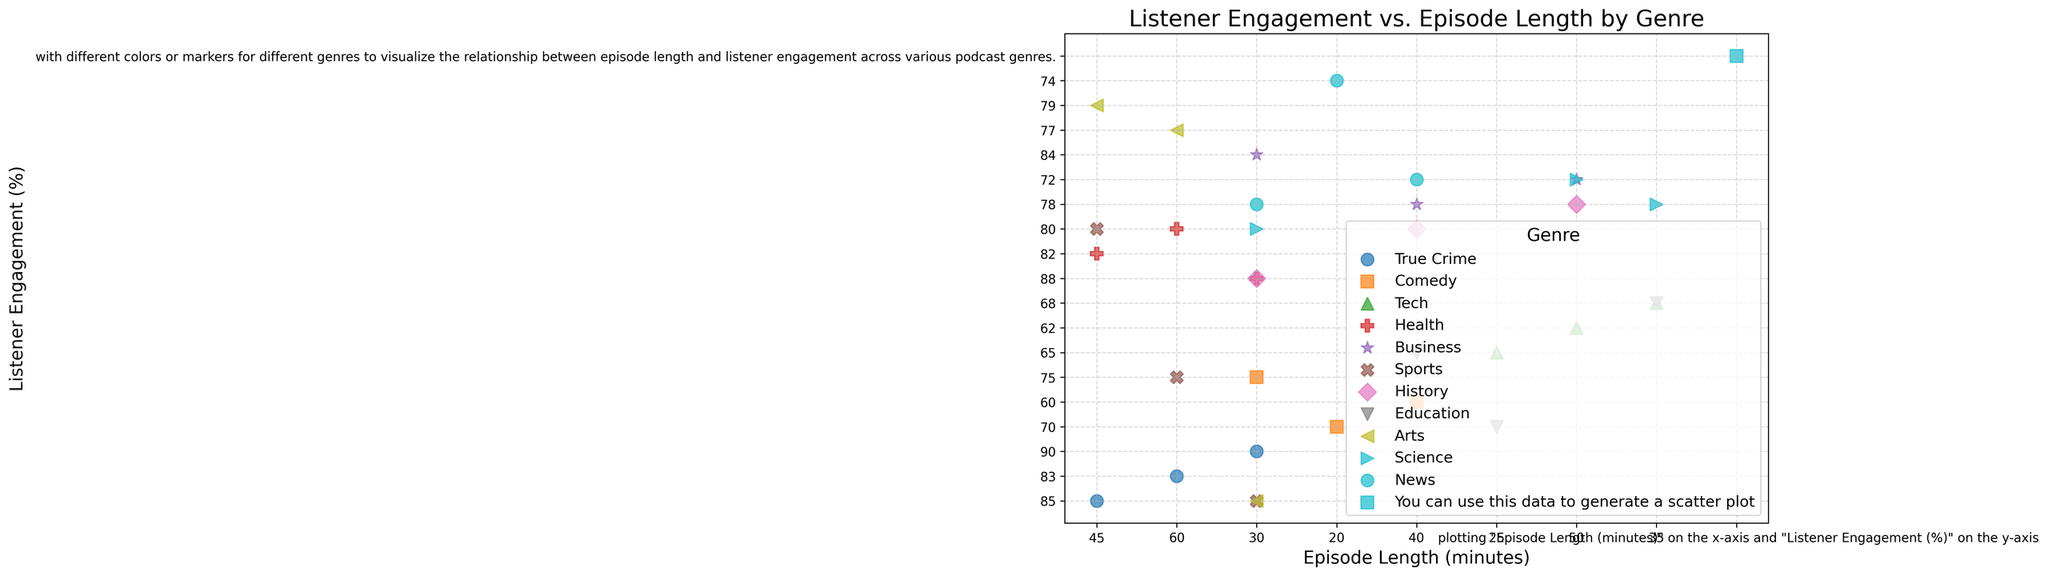What genre shows the highest listener engagement for episode lengths around 30 minutes? Look at the scatter plot, focusing on episode lengths around 30 minutes. Observe which genre's data points are the highest on the y-axis.
Answer: True Crime Which genre has the widest range of episode lengths? Look at each genre's spread on the x-axis (Episode Length). Identify which genre has data points spread out over the longest range.
Answer: Tech Is there a genre where listener engagement tends to decrease as episode length increases? Check the trend (slope direction) of the scatter plot markers for each genre. Identify if there's a genre where the markers consistently go downwards as you move rightwards along the x-axis.
Answer: Comedy Between Sports and Health genres, which one has higher average listener engagement for 45-minute episodes? Identify the data points for 45-minute episodes in both genres. Compare the y-axis (Listener Engagement) values of these data points.
Answer: Health Which genre has a cluster of high listener engagement (above 80%) for episodes shorter than 40 minutes? Focus on the data points above the 80% mark on the y-axis. Check which genre has multiple data points within that subset and episode lengths under 40 minutes.
Answer: Health For episodes around 50 minutes, which genre has the most varied listener engagement? Look at the scatter plot for episodes around 50 minutes on the x-axis and observe the spread of y-values (Listener Engagement) for each genre.
Answer: Tech Do any genres reach listener engagement of 90% or above? If so, which genres? Check the topmost points on the y-axis for values of 90% or more. Note the corresponding genres of these points.
Answer: True Crime, Health, History Is there any genre with consistently low listener engagement, regardless of episode length? Identify any genre with y-axis values that are relatively low across all data points.
Answer: None Which genre shows listener engagement dropping below 65% for episodes longer than 40 minutes? Focus on episodes longer than 40 minutes and check which genre's data points are below 65% on the y-axis.
Answer: Comedy Among True Crime, Business, and Science genres, which one has the highest engagement for 60-minute episodes? Look at the scatter plot points for 60-minute episodes in these three genres. Compare their positions on the y-axis (Listener Engagement).
Answer: True Crime 